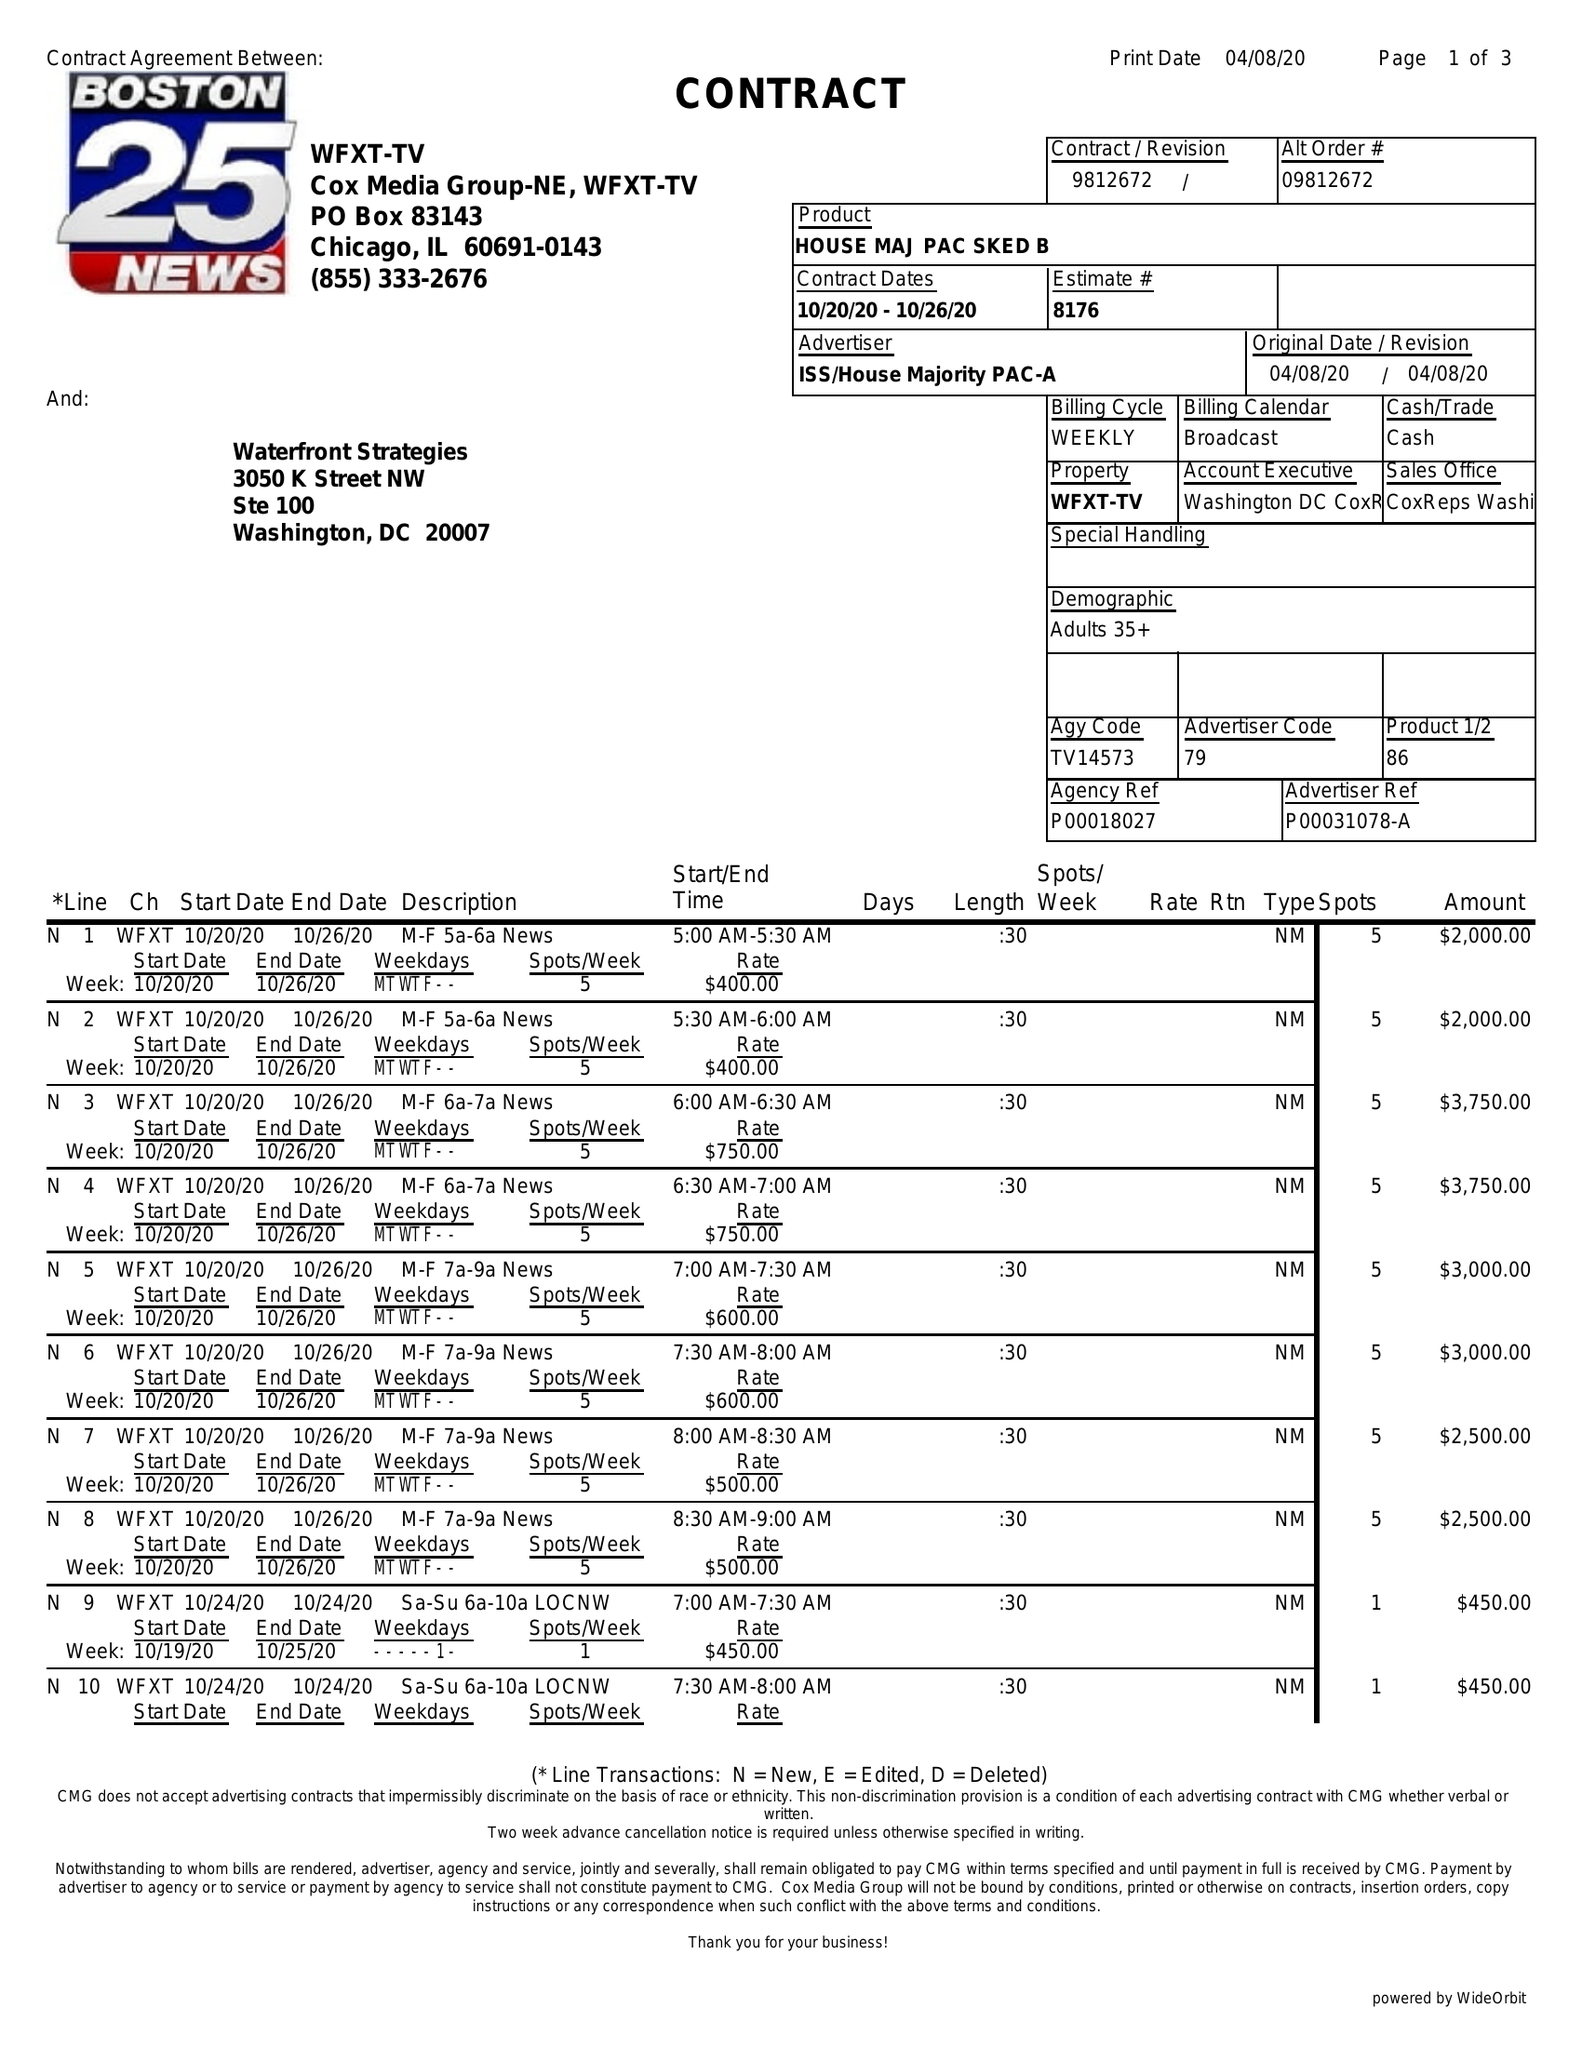What is the value for the advertiser?
Answer the question using a single word or phrase. ISS/HOUSEMAJORITYPAC-A 